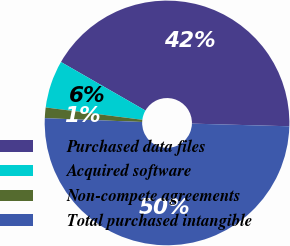Convert chart. <chart><loc_0><loc_0><loc_500><loc_500><pie_chart><fcel>Purchased data files<fcel>Acquired software<fcel>Non-compete agreements<fcel>Total purchased intangible<nl><fcel>42.14%<fcel>6.28%<fcel>1.4%<fcel>50.19%<nl></chart> 